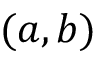<formula> <loc_0><loc_0><loc_500><loc_500>( a , b )</formula> 